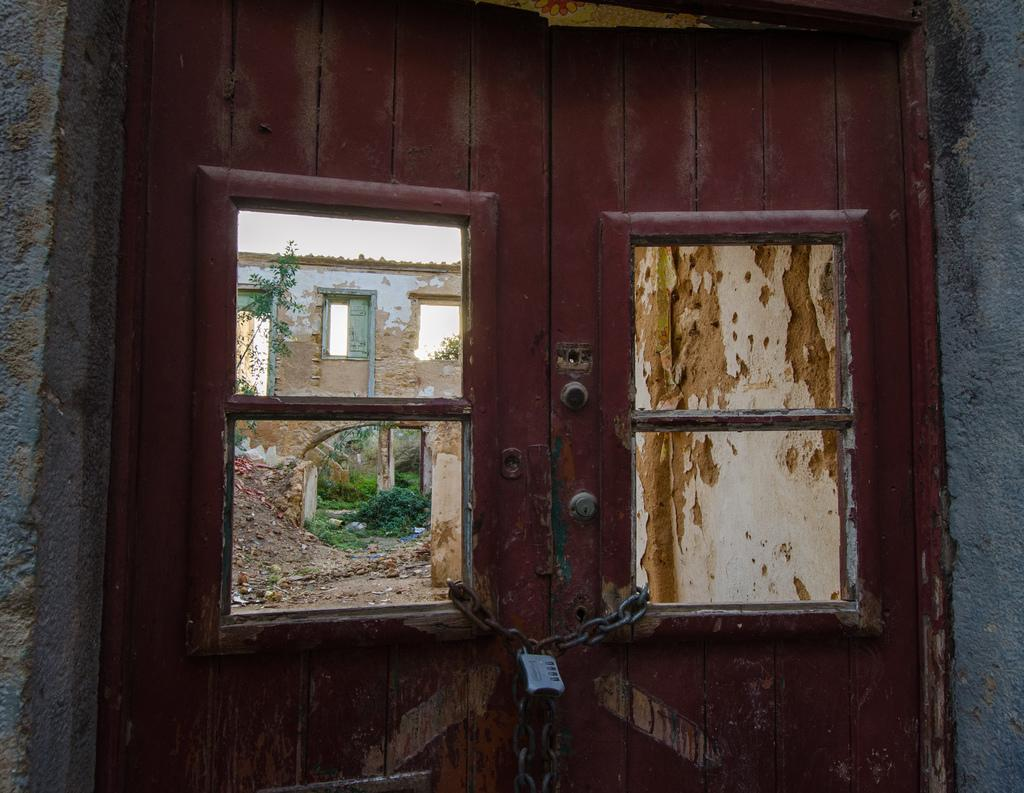What is the status of the doors in the image? The doors in the image are locked. What can be seen through the doors? There is a building visible through the doors. What architectural feature is present in the image? There are windows visible in the image. What type of vegetation is present in the image? There are plants visible in the image, and grass is also present. What is the background of the image? There is a wall visible in the image. What book is the person holding in their hands in the image? There are no people or books visible in the image. What type of structure is depicted in the image? The image does not show a specific structure; it only shows doors, a building, windows, plants, grass, and a wall. 